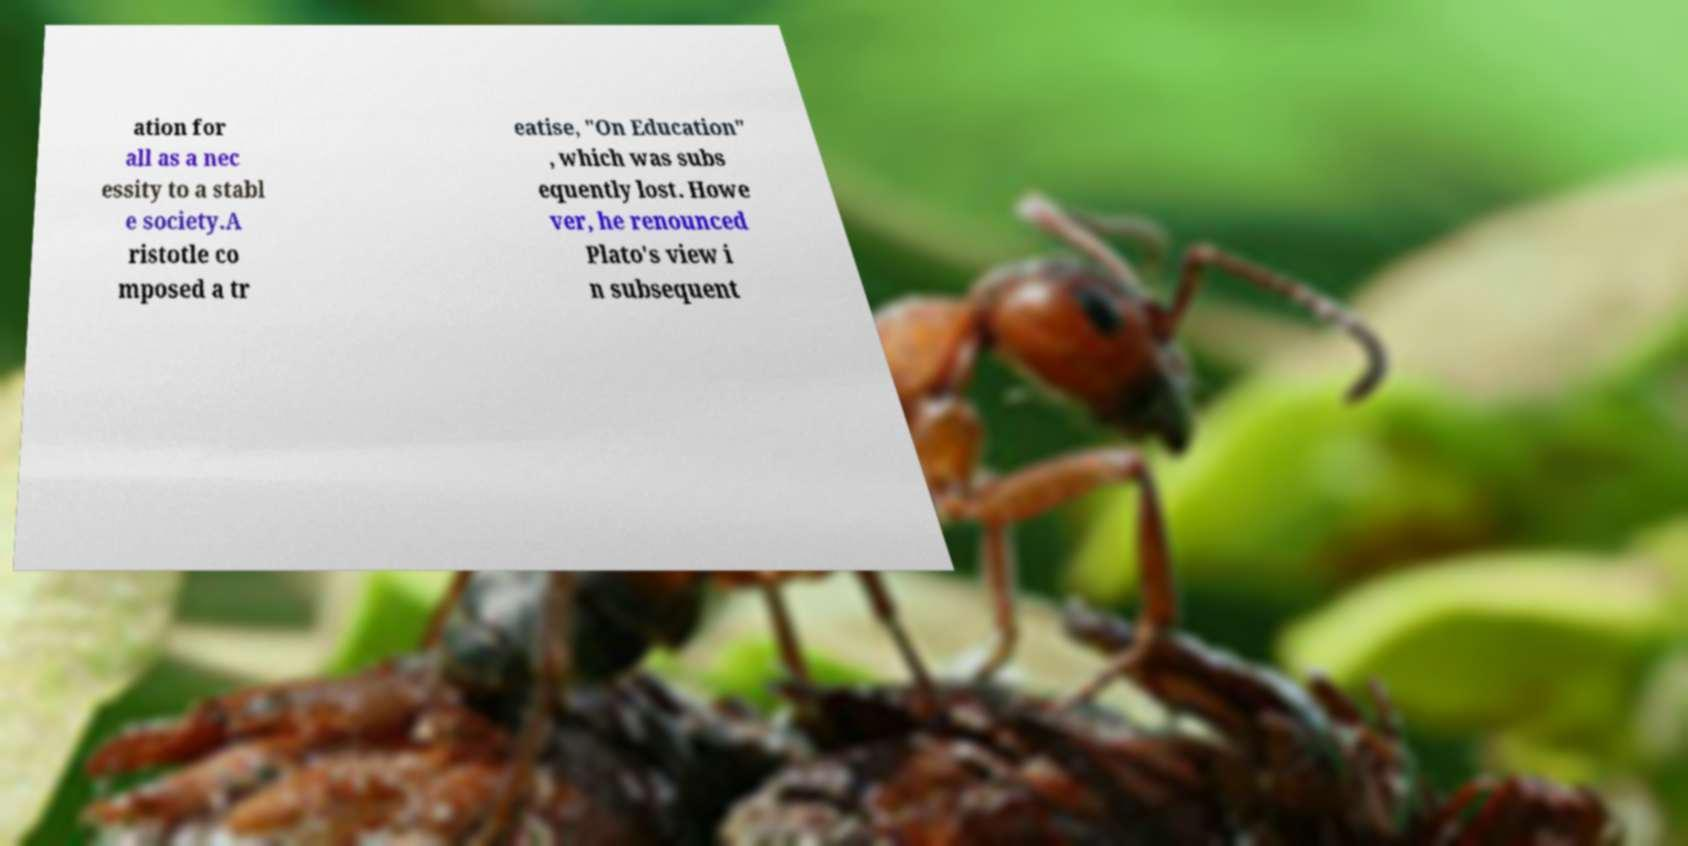Please identify and transcribe the text found in this image. ation for all as a nec essity to a stabl e society.A ristotle co mposed a tr eatise, "On Education" , which was subs equently lost. Howe ver, he renounced Plato's view i n subsequent 